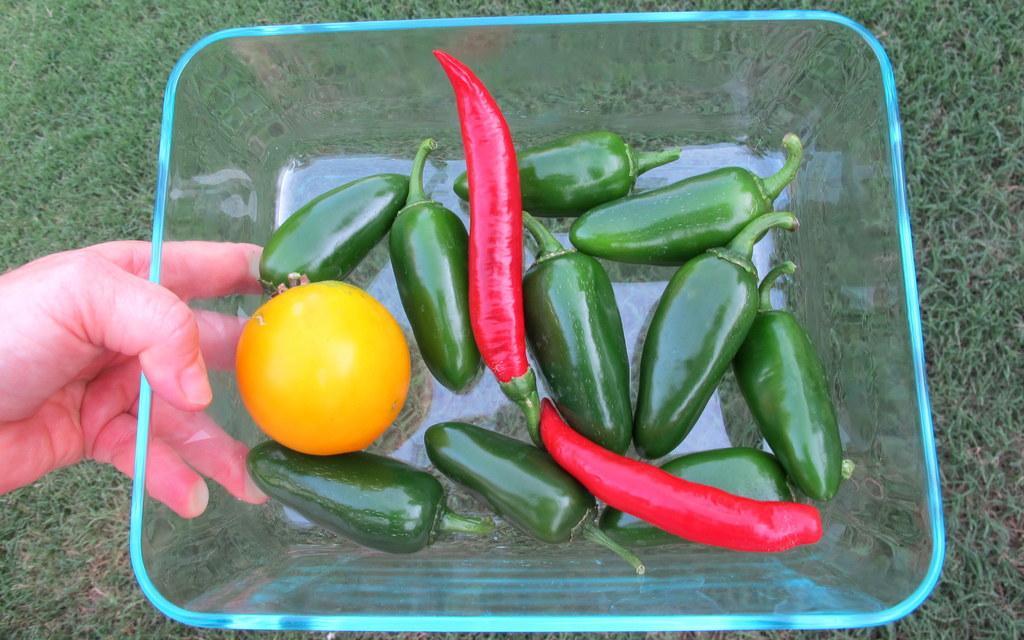How would you summarize this image in a sentence or two? In this image I see a person's hand who is holding a glass bowl on which there are green and red color chillies and a yellow color vegetable over here and in the background I see the green grass. 